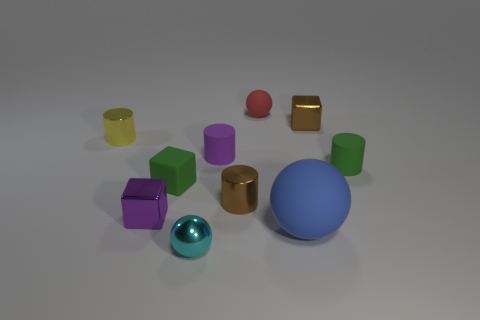Subtract 0 gray spheres. How many objects are left? 10 Subtract all blocks. How many objects are left? 7 Subtract 1 cubes. How many cubes are left? 2 Subtract all brown spheres. Subtract all cyan blocks. How many spheres are left? 3 Subtract all gray blocks. How many yellow spheres are left? 0 Subtract all small matte blocks. Subtract all tiny green objects. How many objects are left? 7 Add 4 tiny red matte spheres. How many tiny red matte spheres are left? 5 Add 1 small green metallic cylinders. How many small green metallic cylinders exist? 1 Subtract all brown cylinders. How many cylinders are left? 3 Subtract all yellow cylinders. How many cylinders are left? 3 